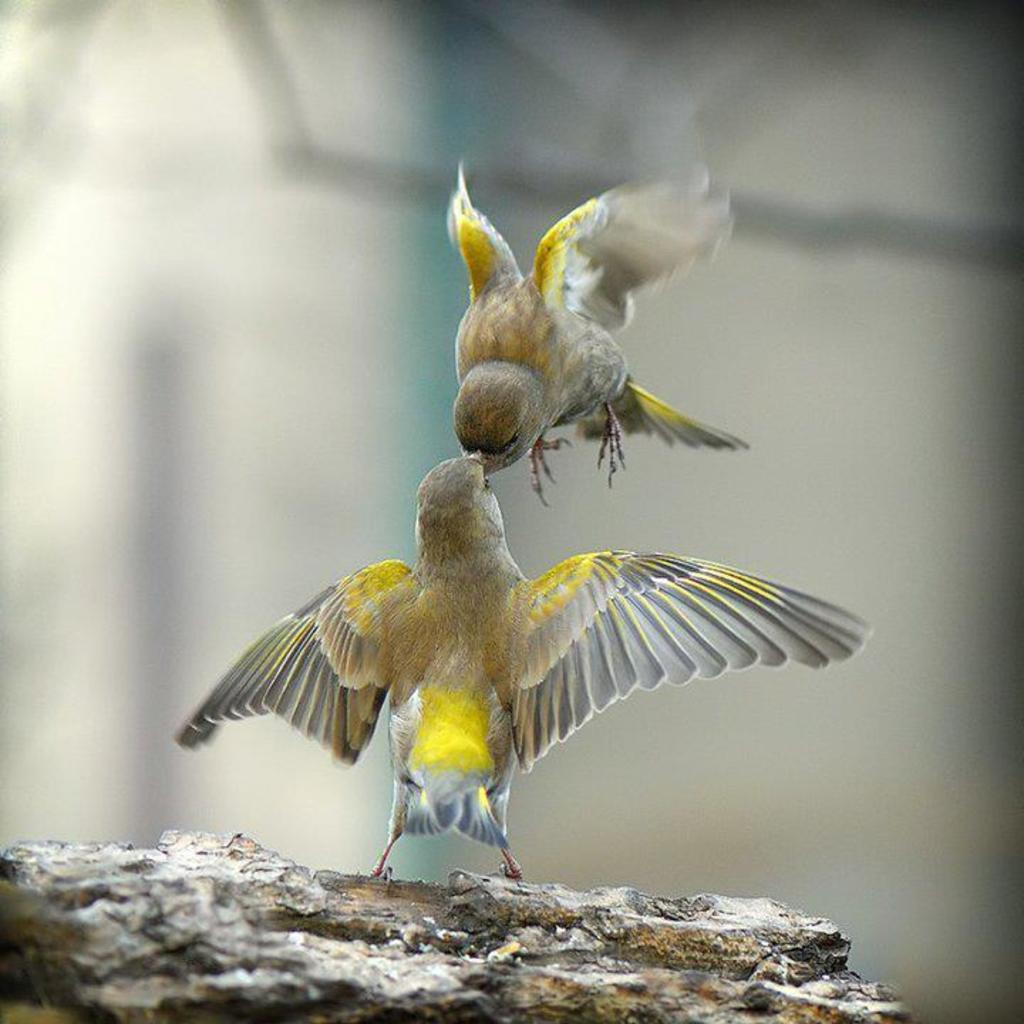How many birds are present in the image? There are two birds in the image. What is the difference in the position of the two birds? One bird is flying, while the other bird is on a rock. Can you describe the background of the image? The backdrop of the image is blurred. Is the bird on the rock driving a car in the image? No, there is no car or driving activity depicted in the image. 